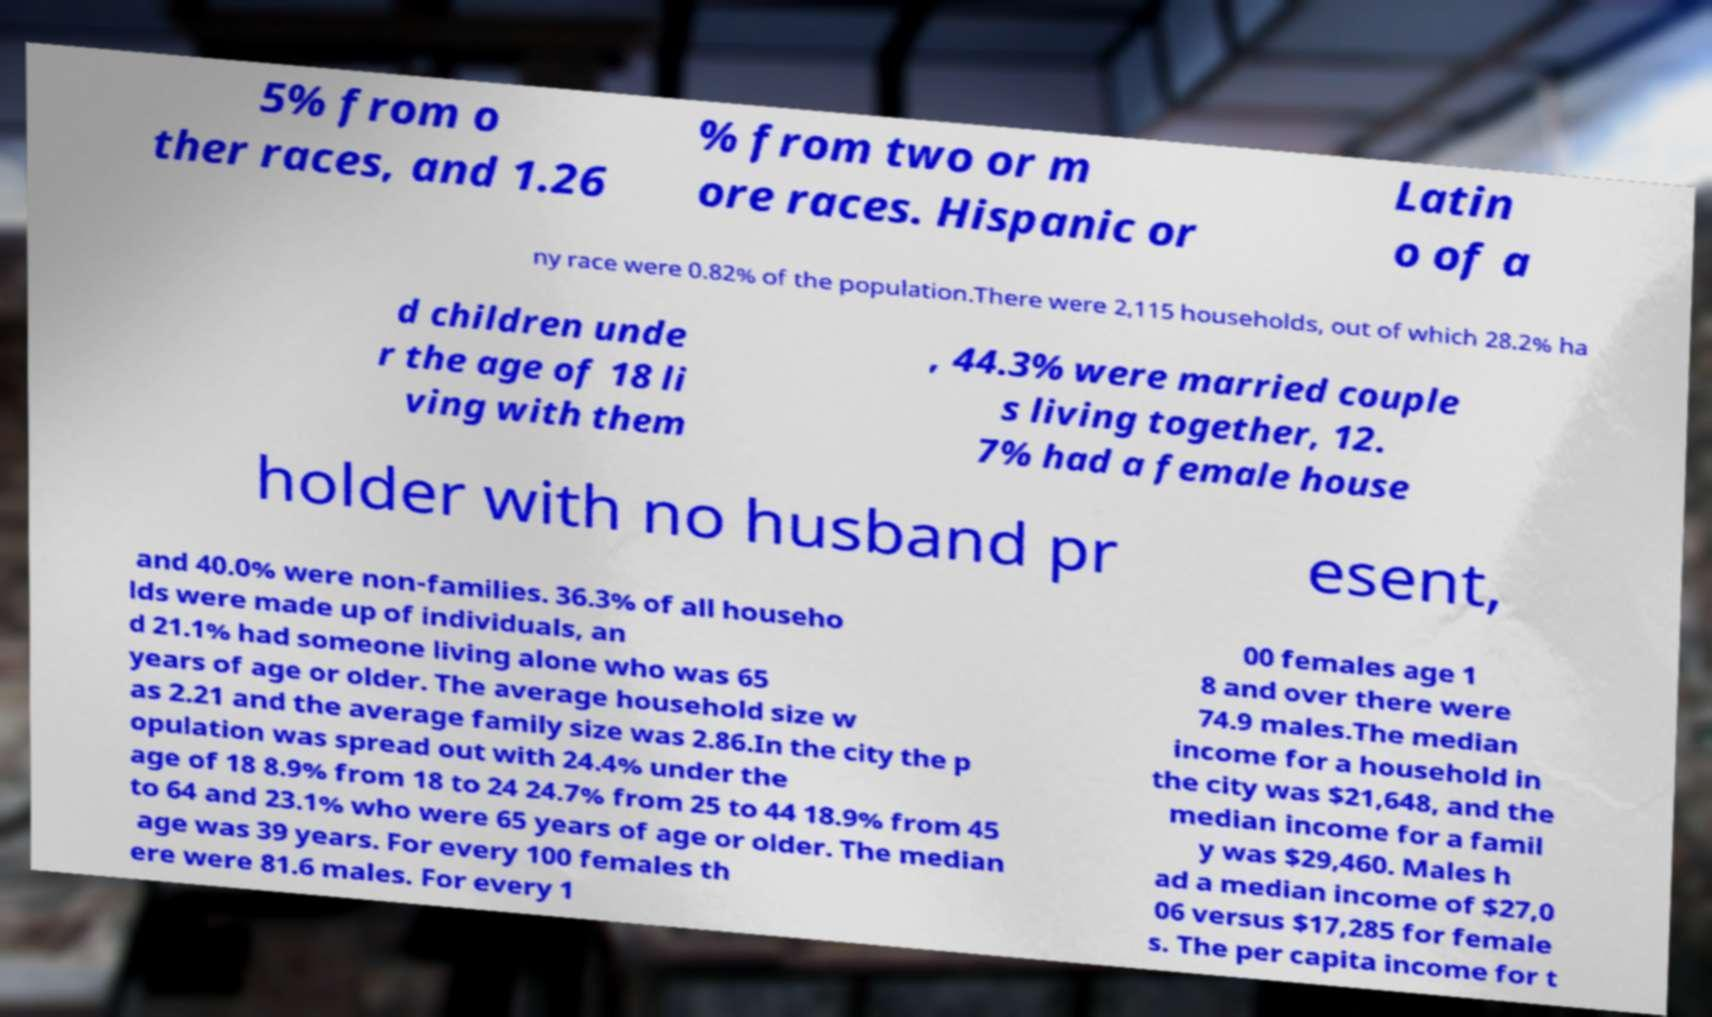Can you read and provide the text displayed in the image?This photo seems to have some interesting text. Can you extract and type it out for me? 5% from o ther races, and 1.26 % from two or m ore races. Hispanic or Latin o of a ny race were 0.82% of the population.There were 2,115 households, out of which 28.2% ha d children unde r the age of 18 li ving with them , 44.3% were married couple s living together, 12. 7% had a female house holder with no husband pr esent, and 40.0% were non-families. 36.3% of all househo lds were made up of individuals, an d 21.1% had someone living alone who was 65 years of age or older. The average household size w as 2.21 and the average family size was 2.86.In the city the p opulation was spread out with 24.4% under the age of 18 8.9% from 18 to 24 24.7% from 25 to 44 18.9% from 45 to 64 and 23.1% who were 65 years of age or older. The median age was 39 years. For every 100 females th ere were 81.6 males. For every 1 00 females age 1 8 and over there were 74.9 males.The median income for a household in the city was $21,648, and the median income for a famil y was $29,460. Males h ad a median income of $27,0 06 versus $17,285 for female s. The per capita income for t 